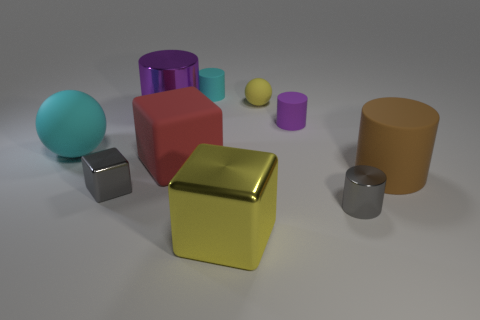Do the yellow block and the small cyan object have the same material?
Provide a short and direct response. No. How many yellow metallic blocks are the same size as the gray cylinder?
Offer a terse response. 0. Are there an equal number of tiny spheres in front of the red block and yellow shiny cylinders?
Your answer should be very brief. Yes. How many tiny objects are behind the tiny gray block and to the left of the small yellow thing?
Make the answer very short. 1. Does the metallic object behind the large brown object have the same shape as the tiny purple object?
Make the answer very short. Yes. There is a gray cube that is the same size as the purple matte thing; what is its material?
Provide a succinct answer. Metal. Are there the same number of tiny rubber spheres on the left side of the purple metallic cylinder and tiny cyan matte objects behind the cyan matte sphere?
Provide a succinct answer. No. There is a large cyan rubber object on the left side of the ball behind the tiny purple rubber cylinder; how many big rubber spheres are in front of it?
Your answer should be very brief. 0. Does the big matte cylinder have the same color as the big rubber object that is behind the red rubber cube?
Keep it short and to the point. No. What size is the gray block that is made of the same material as the large purple cylinder?
Your answer should be compact. Small. 